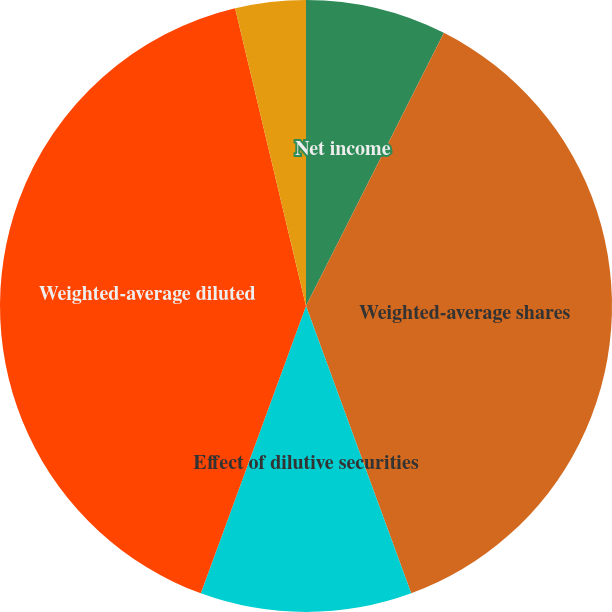Convert chart. <chart><loc_0><loc_0><loc_500><loc_500><pie_chart><fcel>Net income<fcel>Weighted-average shares<fcel>Effect of dilutive securities<fcel>Weighted-average diluted<fcel>Basic earnings per share<fcel>Diluted earnings per share<nl><fcel>7.44%<fcel>36.97%<fcel>11.17%<fcel>40.69%<fcel>3.72%<fcel>0.0%<nl></chart> 